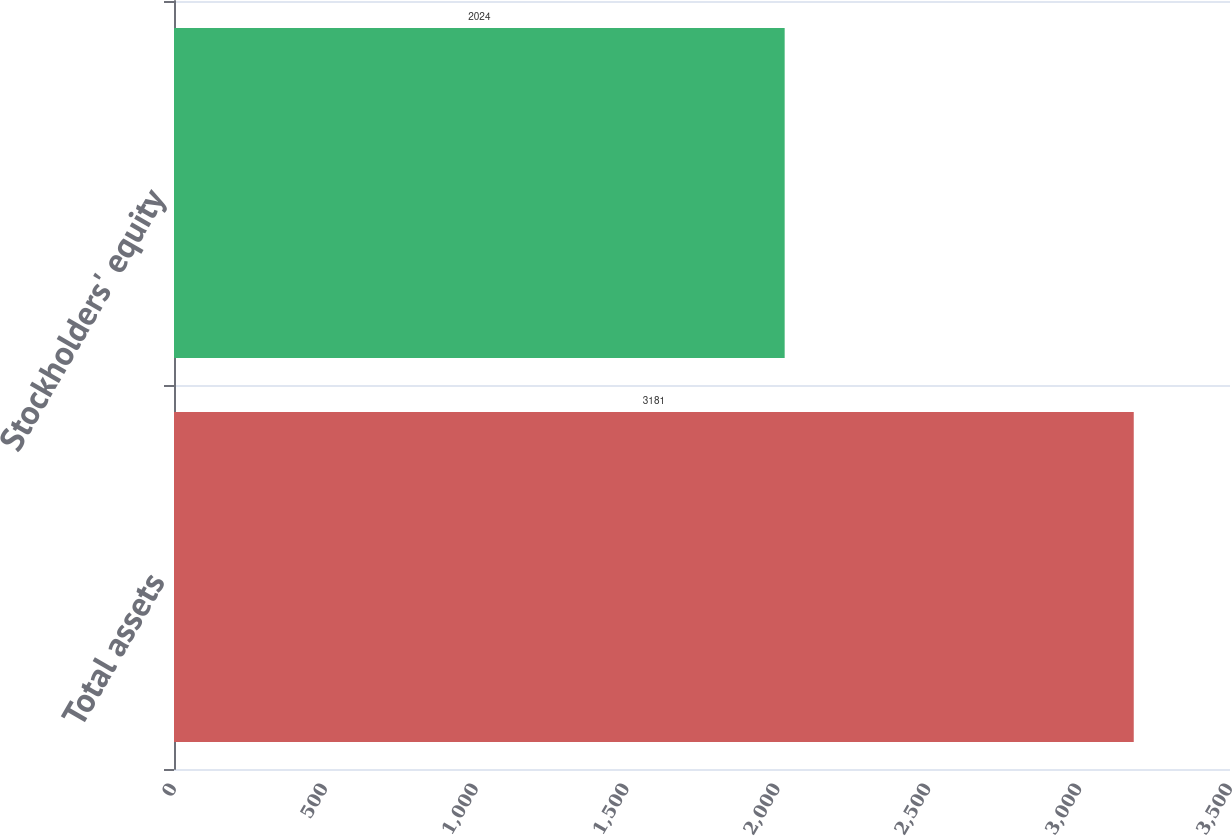Convert chart to OTSL. <chart><loc_0><loc_0><loc_500><loc_500><bar_chart><fcel>Total assets<fcel>Stockholders' equity<nl><fcel>3181<fcel>2024<nl></chart> 